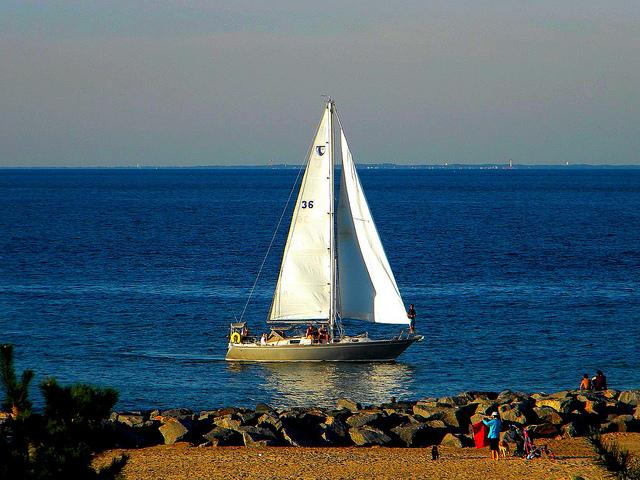How many sails are attached to the boat in the ocean? two 